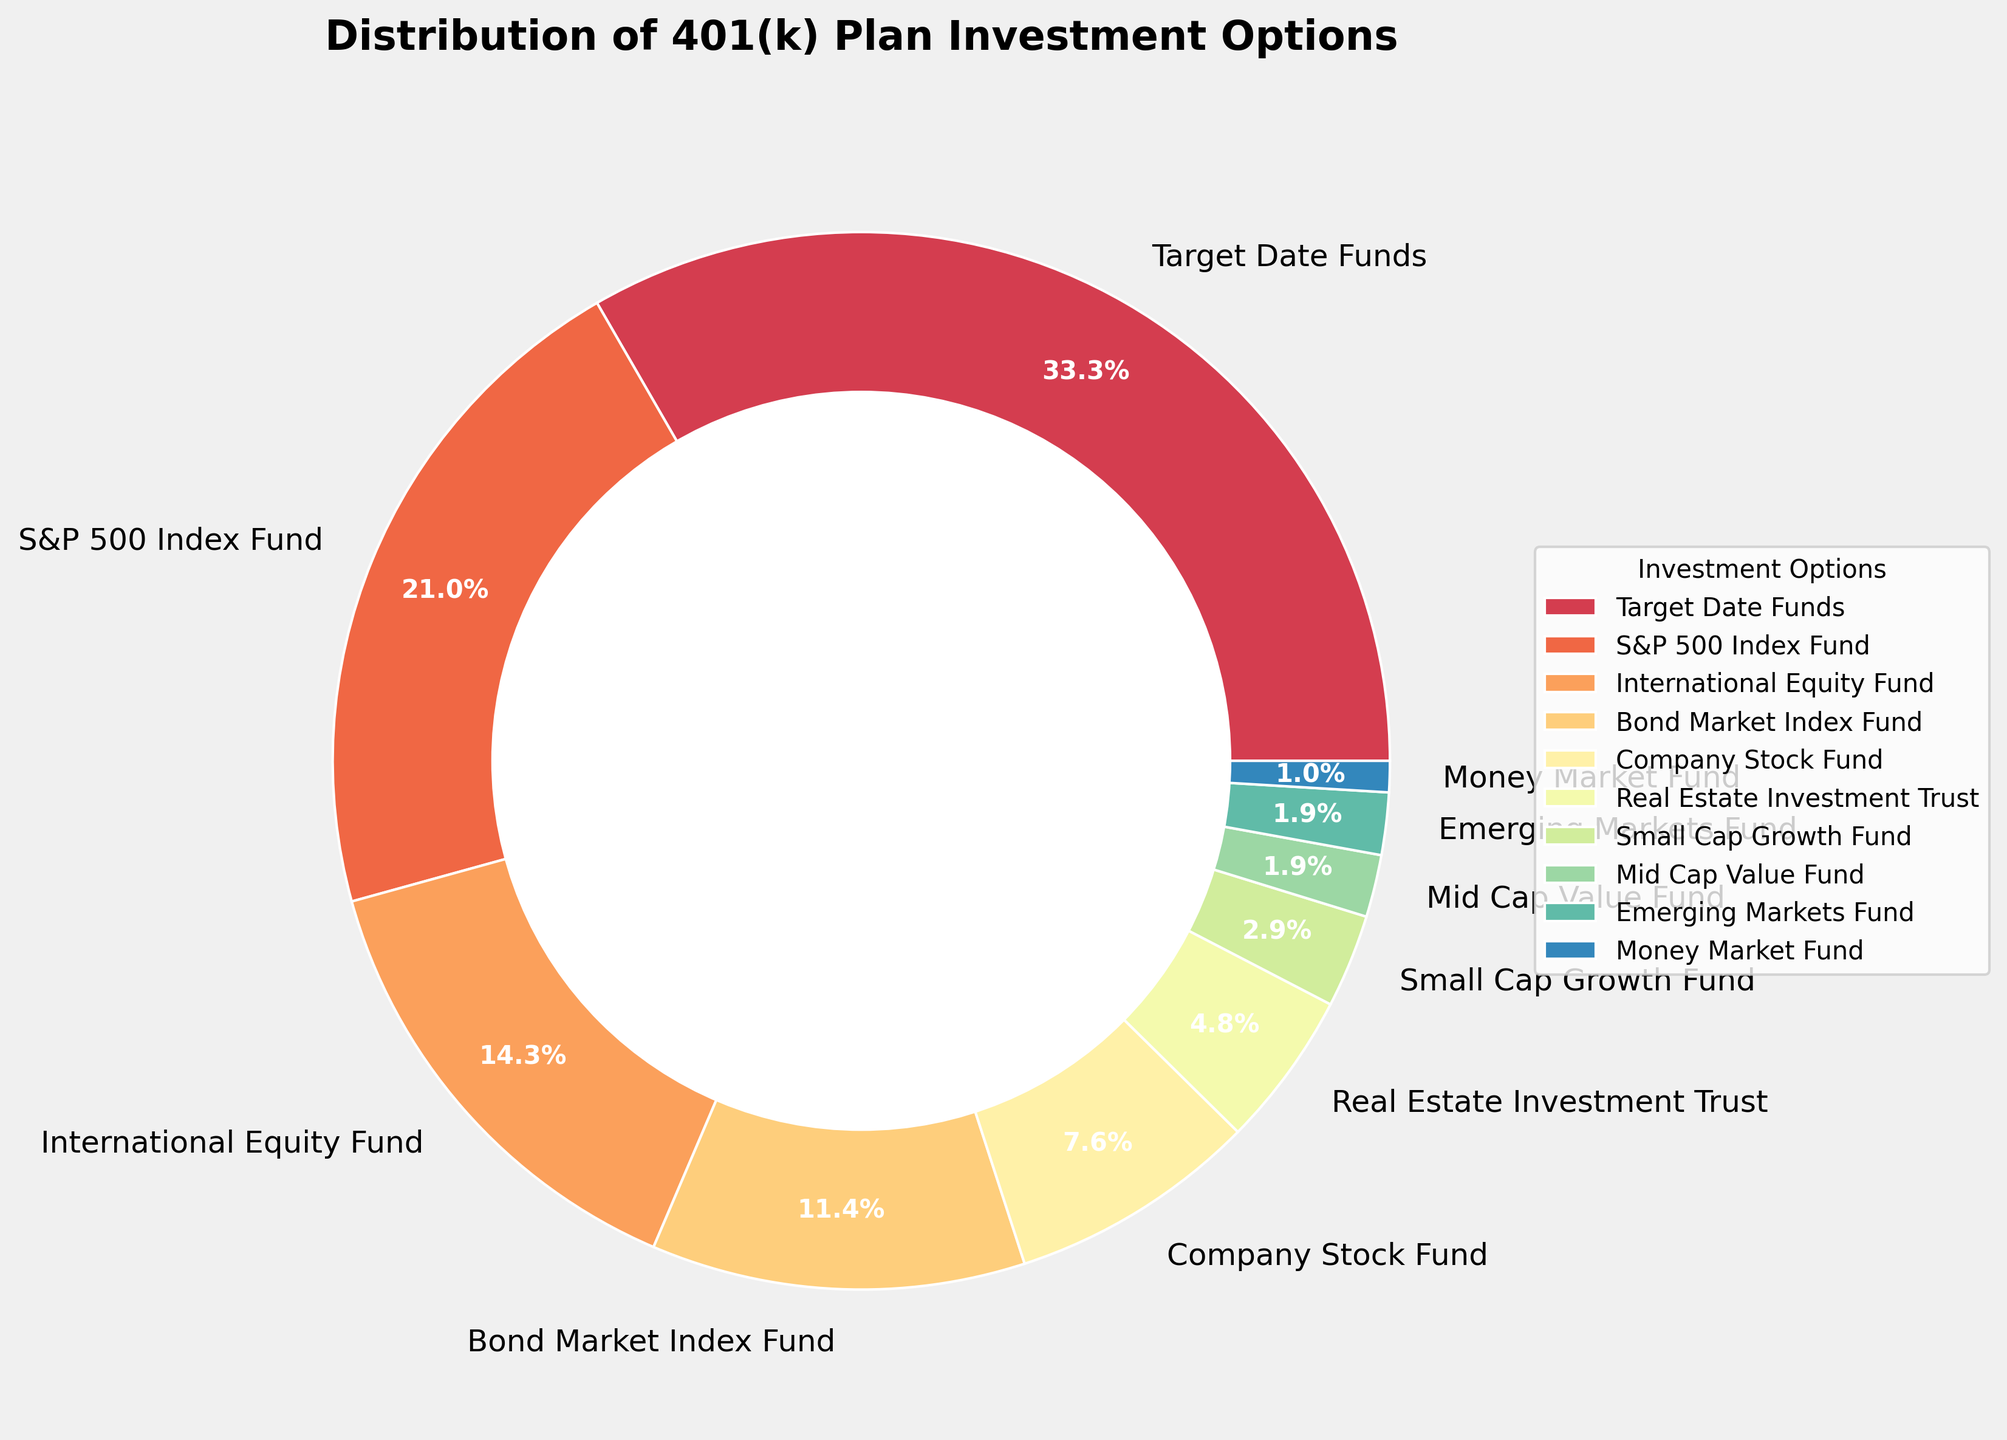Which investment option holds the highest percentage in the 401(k) plan? The visual indicates that the 'Target Date Funds' slice is the largest.
Answer: Target Date Funds What is the combined percentage of the S&P 500 Index Fund and the International Equity Fund? Sum the percentages of S&P 500 Index Fund (22%) and International Equity Fund (15%). So, 22% + 15% = 37%.
Answer: 37% Which two investment options have the lowest contributions, and what are their percentages combined? The slices for 'Mid Cap Value Fund' (2%) and 'Money Market Fund' (1%) are the smallest. Combine their percentages: 2% + 1% = 3%.
Answer: Mid Cap Value Fund and Money Market Fund, 3% How does the contribution to the Bond Market Index Fund compare to that of the Company Stock Fund? The Bond Market Index Fund is represented by a larger slice (12%) compared to the Company Stock Fund (8%). Thus, the Bond Market Index Fund has a higher contribution.
Answer: Bond Market Index Fund has a higher contribution than Company Stock Fund What's the difference in percentage between the highest and lowest investment options? The highest is 'Target Date Funds' with 35% and the lowest is 'Money Market Fund' with 1%. Difference: 35% - 1% = 34%.
Answer: 34% What percentage of the total is invested in funds explicitly containing equity (S&P 500 Index Fund, International Equity Fund, Small Cap Growth Fund)? Combine the percentages: S&P 500 Index Fund (22%) + International Equity Fund (15%) + Small Cap Growth Fund (3%) = 22% + 15% + 3% = 40%.
Answer: 40% Is the contribution to the Real Estate Investment Trust greater than or equal to the contribution to the Company Stock Fund? Real Estate Investment Trust has 5%, and Company Stock Fund has 8%. 5% < 8%, hence the contribution is less.
Answer: No, it's less What is the percentage contribution of mid-cap and small-cap related funds combined? Add contributions of the 'Small Cap Growth Fund' (3%) and 'Mid Cap Value Fund' (2%): 3% + 2% = 5%.
Answer: 5% 